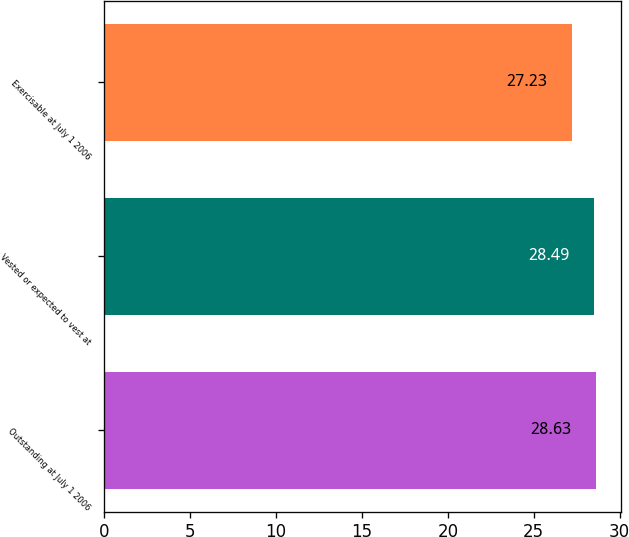<chart> <loc_0><loc_0><loc_500><loc_500><bar_chart><fcel>Outstanding at July 1 2006<fcel>Vested or expected to vest at<fcel>Exercisable at July 1 2006<nl><fcel>28.63<fcel>28.49<fcel>27.23<nl></chart> 